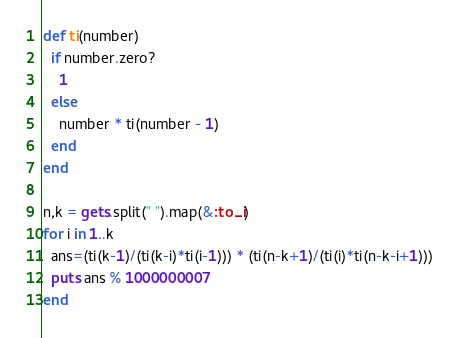Convert code to text. <code><loc_0><loc_0><loc_500><loc_500><_Ruby_>def ti(number)
  if number.zero?
    1
  else
    number * ti(number - 1)
  end
end

n,k = gets.split(" ").map(&:to_i)
for i in 1..k
  ans=(ti(k-1)/(ti(k-i)*ti(i-1))) * (ti(n-k+1)/(ti(i)*ti(n-k-i+1)))
  puts ans % 1000000007
end
</code> 